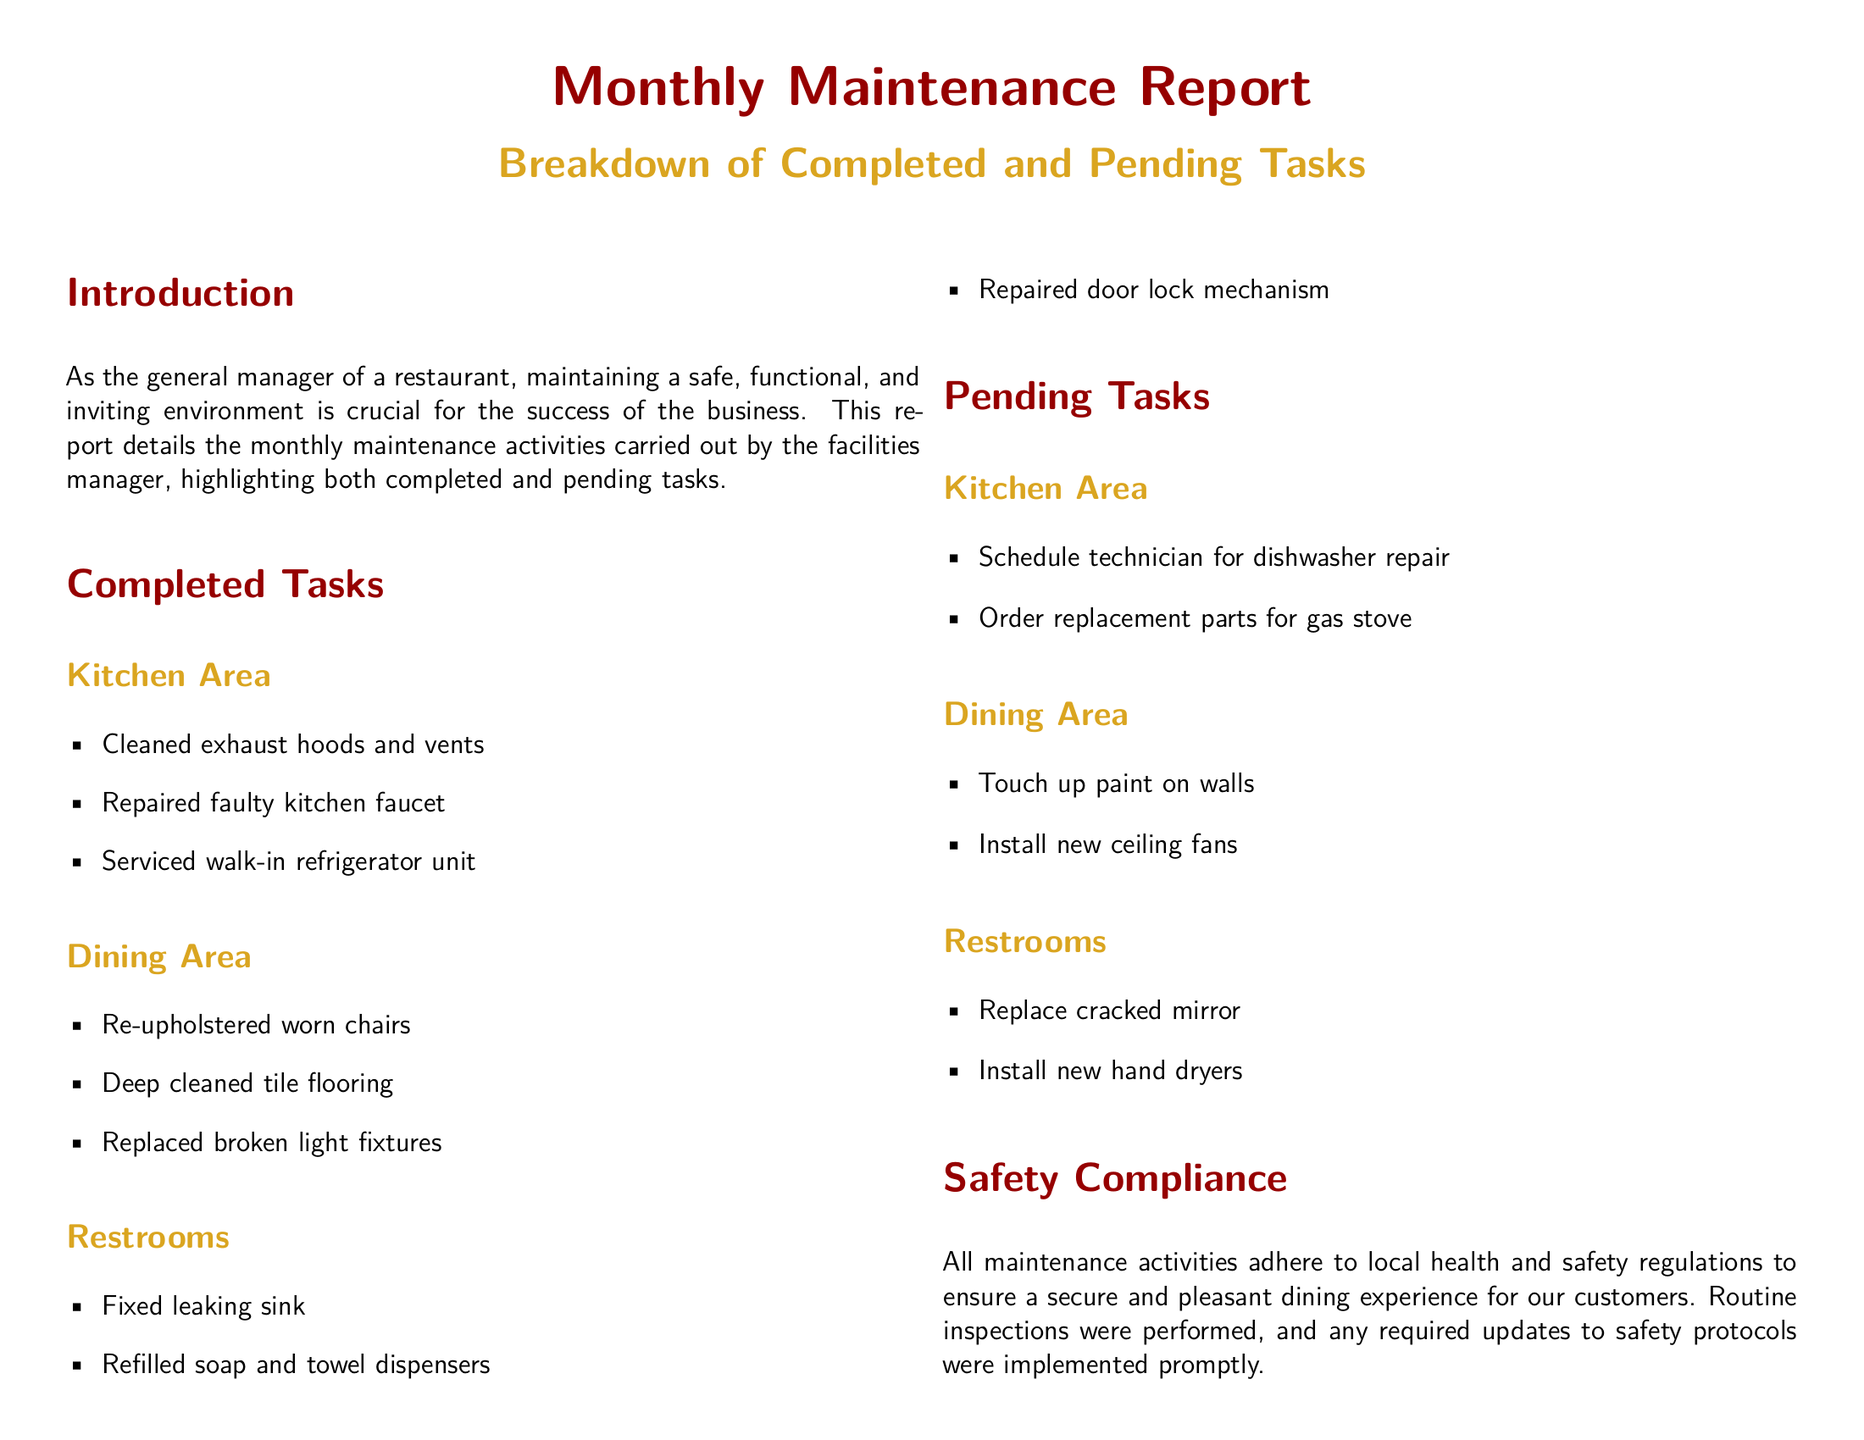What is the title of the document? The title of the document is clearly stated at the beginning, indicating its purpose and subject matter.
Answer: Monthly Maintenance Report What is one completed task in the restroom? The section for completed tasks in the restroom lists specific activities related to maintenance.
Answer: Fixed leaking sink How many completed tasks are listed in the dining area? The completed tasks section for the dining area contains a numbered list of tasks performed.
Answer: Three What is one pending task in the kitchen area? The pending tasks section specifies tasks that have not yet been completed, categorized by area.
Answer: Schedule technician for dishwasher repair What note did the facilities manager include about the plumbing system? The notes and observations section provides insights regarding potential future concerns highlighted by the facilities manager.
Answer: Aging What color is used for section titles in the document? The document specifies color coding for different elements, including section titles.
Answer: Restaurant red How many areas are covered in the maintenance tasks? The report organizes maintenance tasks by different areas, summarizing tasks completed and pending.
Answer: Three What is the purpose of the Monthly Maintenance Report? The introduction section provides insight into the overall goal of the report and its relevance to the restaurant's management.
Answer: Maintain a safe, functional, and inviting environment 